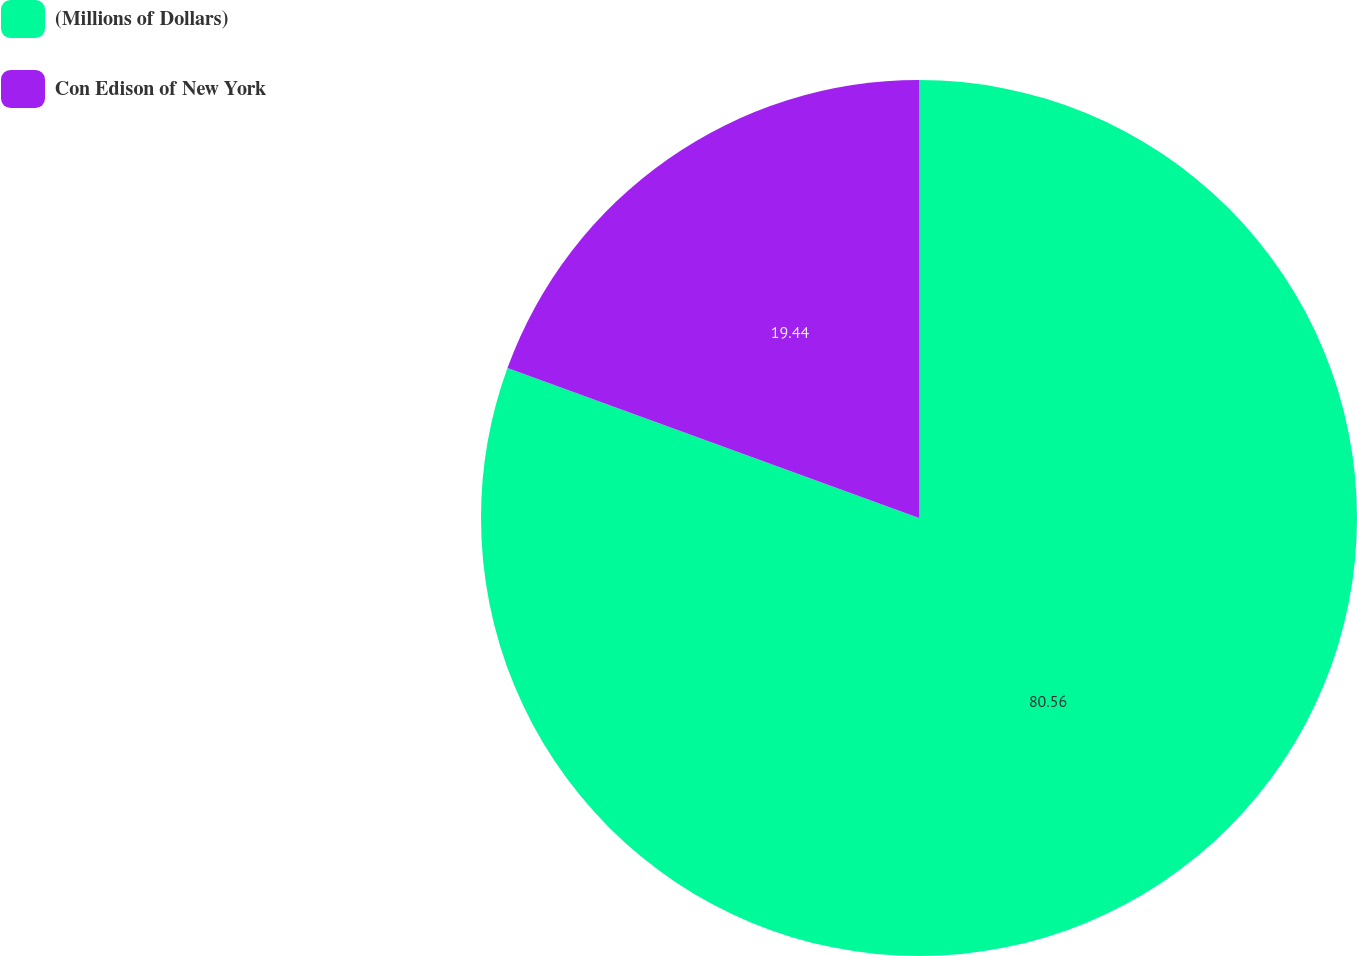Convert chart to OTSL. <chart><loc_0><loc_0><loc_500><loc_500><pie_chart><fcel>(Millions of Dollars)<fcel>Con Edison of New York<nl><fcel>80.56%<fcel>19.44%<nl></chart> 